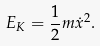Convert formula to latex. <formula><loc_0><loc_0><loc_500><loc_500>E _ { K } = \frac { 1 } { 2 } m \dot { x } ^ { 2 } .</formula> 